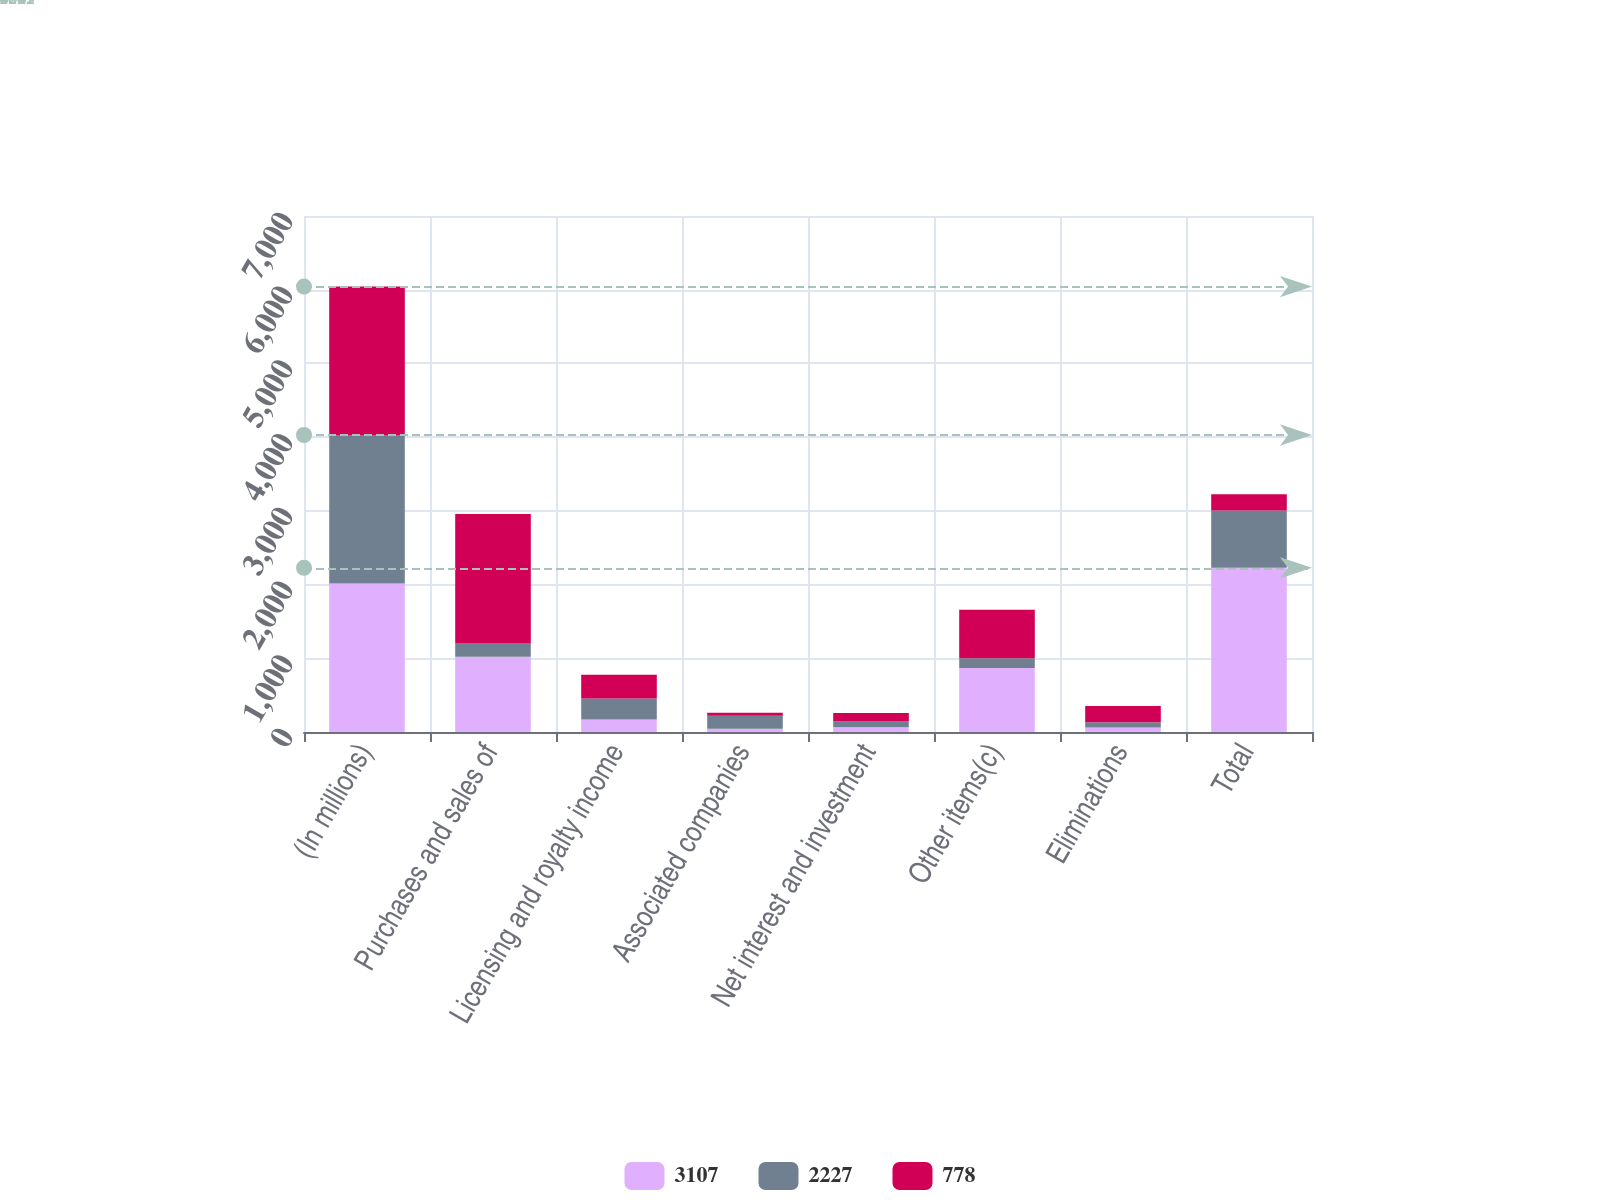<chart> <loc_0><loc_0><loc_500><loc_500><stacked_bar_chart><ecel><fcel>(In millions)<fcel>Purchases and sales of<fcel>Licensing and royalty income<fcel>Associated companies<fcel>Net interest and investment<fcel>Other items(c)<fcel>Eliminations<fcel>Total<nl><fcel>3107<fcel>2015<fcel>1020<fcel>168<fcel>45<fcel>65<fcel>868<fcel>62<fcel>2227<nl><fcel>2227<fcel>2014<fcel>188<fcel>288<fcel>176<fcel>77<fcel>132<fcel>71<fcel>778<nl><fcel>778<fcel>2013<fcel>1750<fcel>320<fcel>40<fcel>116<fcel>660<fcel>221<fcel>221<nl></chart> 